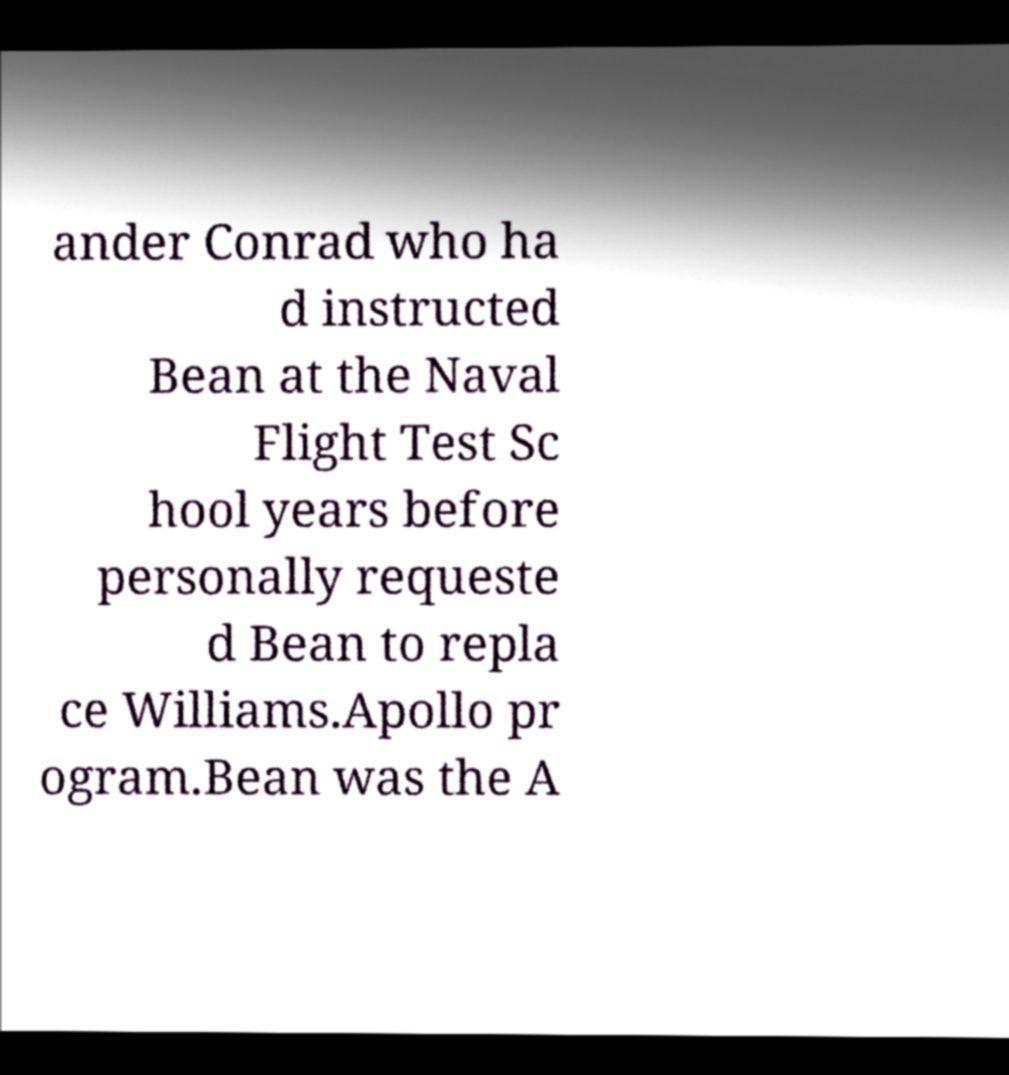There's text embedded in this image that I need extracted. Can you transcribe it verbatim? ander Conrad who ha d instructed Bean at the Naval Flight Test Sc hool years before personally requeste d Bean to repla ce Williams.Apollo pr ogram.Bean was the A 